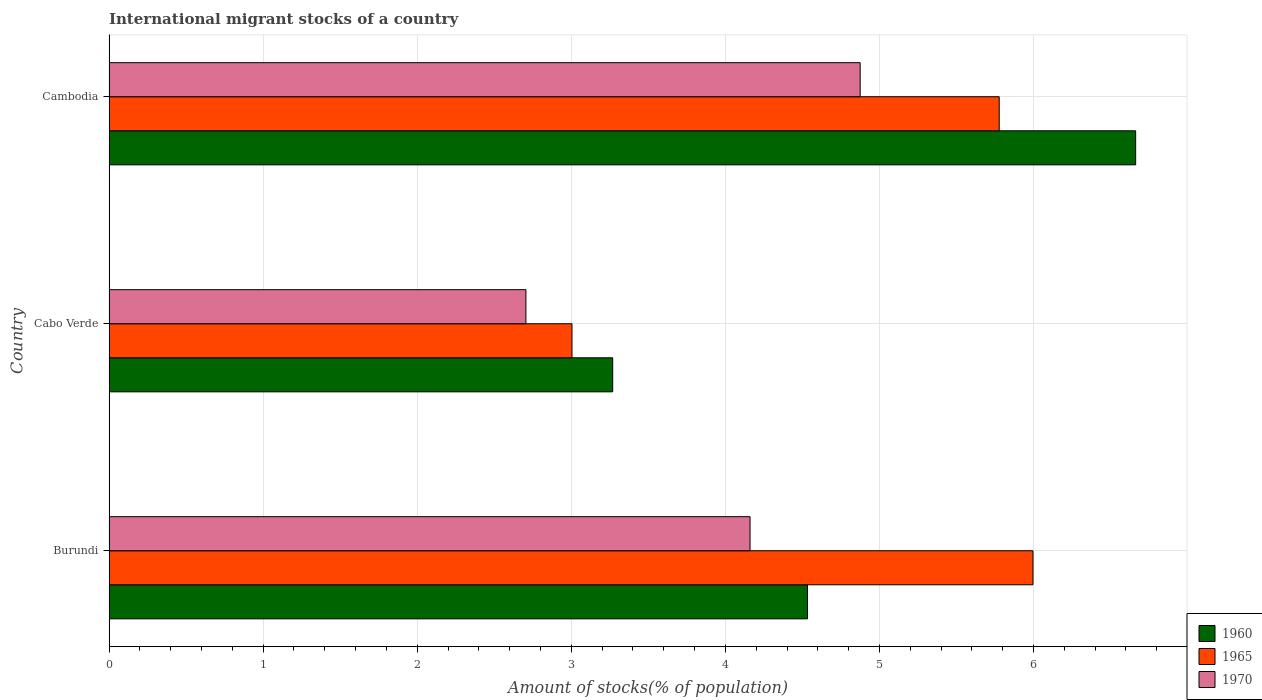How many different coloured bars are there?
Your response must be concise. 3. How many bars are there on the 3rd tick from the bottom?
Your answer should be very brief. 3. What is the label of the 2nd group of bars from the top?
Your answer should be compact. Cabo Verde. What is the amount of stocks in in 1970 in Cabo Verde?
Your response must be concise. 2.71. Across all countries, what is the maximum amount of stocks in in 1960?
Make the answer very short. 6.66. Across all countries, what is the minimum amount of stocks in in 1965?
Your answer should be very brief. 3. In which country was the amount of stocks in in 1960 maximum?
Offer a terse response. Cambodia. In which country was the amount of stocks in in 1970 minimum?
Provide a succinct answer. Cabo Verde. What is the total amount of stocks in in 1965 in the graph?
Your response must be concise. 14.78. What is the difference between the amount of stocks in in 1970 in Burundi and that in Cabo Verde?
Your answer should be compact. 1.45. What is the difference between the amount of stocks in in 1965 in Burundi and the amount of stocks in in 1960 in Cambodia?
Keep it short and to the point. -0.67. What is the average amount of stocks in in 1965 per country?
Give a very brief answer. 4.93. What is the difference between the amount of stocks in in 1965 and amount of stocks in in 1970 in Cambodia?
Keep it short and to the point. 0.9. In how many countries, is the amount of stocks in in 1960 greater than 6.4 %?
Give a very brief answer. 1. What is the ratio of the amount of stocks in in 1960 in Cabo Verde to that in Cambodia?
Your answer should be compact. 0.49. What is the difference between the highest and the second highest amount of stocks in in 1965?
Your answer should be compact. 0.22. What is the difference between the highest and the lowest amount of stocks in in 1965?
Provide a short and direct response. 2.99. Is the sum of the amount of stocks in in 1960 in Cabo Verde and Cambodia greater than the maximum amount of stocks in in 1965 across all countries?
Offer a very short reply. Yes. What does the 1st bar from the top in Burundi represents?
Make the answer very short. 1970. What does the 3rd bar from the bottom in Burundi represents?
Offer a terse response. 1970. How many bars are there?
Offer a terse response. 9. Are all the bars in the graph horizontal?
Offer a very short reply. Yes. What is the difference between two consecutive major ticks on the X-axis?
Your answer should be very brief. 1. Does the graph contain any zero values?
Your answer should be compact. No. How many legend labels are there?
Your answer should be compact. 3. What is the title of the graph?
Your answer should be compact. International migrant stocks of a country. What is the label or title of the X-axis?
Offer a very short reply. Amount of stocks(% of population). What is the Amount of stocks(% of population) in 1960 in Burundi?
Ensure brevity in your answer.  4.53. What is the Amount of stocks(% of population) in 1965 in Burundi?
Provide a succinct answer. 6. What is the Amount of stocks(% of population) of 1970 in Burundi?
Provide a succinct answer. 4.16. What is the Amount of stocks(% of population) in 1960 in Cabo Verde?
Your response must be concise. 3.27. What is the Amount of stocks(% of population) in 1965 in Cabo Verde?
Provide a short and direct response. 3. What is the Amount of stocks(% of population) of 1970 in Cabo Verde?
Your response must be concise. 2.71. What is the Amount of stocks(% of population) in 1960 in Cambodia?
Provide a succinct answer. 6.66. What is the Amount of stocks(% of population) in 1965 in Cambodia?
Offer a very short reply. 5.78. What is the Amount of stocks(% of population) of 1970 in Cambodia?
Provide a short and direct response. 4.87. Across all countries, what is the maximum Amount of stocks(% of population) of 1960?
Provide a short and direct response. 6.66. Across all countries, what is the maximum Amount of stocks(% of population) in 1965?
Your answer should be compact. 6. Across all countries, what is the maximum Amount of stocks(% of population) of 1970?
Provide a short and direct response. 4.87. Across all countries, what is the minimum Amount of stocks(% of population) in 1960?
Provide a succinct answer. 3.27. Across all countries, what is the minimum Amount of stocks(% of population) in 1965?
Your response must be concise. 3. Across all countries, what is the minimum Amount of stocks(% of population) in 1970?
Make the answer very short. 2.71. What is the total Amount of stocks(% of population) in 1960 in the graph?
Your answer should be very brief. 14.46. What is the total Amount of stocks(% of population) in 1965 in the graph?
Make the answer very short. 14.78. What is the total Amount of stocks(% of population) of 1970 in the graph?
Give a very brief answer. 11.74. What is the difference between the Amount of stocks(% of population) in 1960 in Burundi and that in Cabo Verde?
Make the answer very short. 1.26. What is the difference between the Amount of stocks(% of population) of 1965 in Burundi and that in Cabo Verde?
Keep it short and to the point. 2.99. What is the difference between the Amount of stocks(% of population) of 1970 in Burundi and that in Cabo Verde?
Offer a terse response. 1.45. What is the difference between the Amount of stocks(% of population) of 1960 in Burundi and that in Cambodia?
Ensure brevity in your answer.  -2.13. What is the difference between the Amount of stocks(% of population) of 1965 in Burundi and that in Cambodia?
Provide a short and direct response. 0.22. What is the difference between the Amount of stocks(% of population) in 1970 in Burundi and that in Cambodia?
Provide a short and direct response. -0.71. What is the difference between the Amount of stocks(% of population) of 1960 in Cabo Verde and that in Cambodia?
Give a very brief answer. -3.39. What is the difference between the Amount of stocks(% of population) of 1965 in Cabo Verde and that in Cambodia?
Offer a terse response. -2.77. What is the difference between the Amount of stocks(% of population) in 1970 in Cabo Verde and that in Cambodia?
Make the answer very short. -2.17. What is the difference between the Amount of stocks(% of population) of 1960 in Burundi and the Amount of stocks(% of population) of 1965 in Cabo Verde?
Offer a terse response. 1.53. What is the difference between the Amount of stocks(% of population) in 1960 in Burundi and the Amount of stocks(% of population) in 1970 in Cabo Verde?
Offer a terse response. 1.83. What is the difference between the Amount of stocks(% of population) in 1965 in Burundi and the Amount of stocks(% of population) in 1970 in Cabo Verde?
Provide a succinct answer. 3.29. What is the difference between the Amount of stocks(% of population) in 1960 in Burundi and the Amount of stocks(% of population) in 1965 in Cambodia?
Offer a terse response. -1.24. What is the difference between the Amount of stocks(% of population) of 1960 in Burundi and the Amount of stocks(% of population) of 1970 in Cambodia?
Offer a terse response. -0.34. What is the difference between the Amount of stocks(% of population) of 1965 in Burundi and the Amount of stocks(% of population) of 1970 in Cambodia?
Give a very brief answer. 1.12. What is the difference between the Amount of stocks(% of population) of 1960 in Cabo Verde and the Amount of stocks(% of population) of 1965 in Cambodia?
Make the answer very short. -2.51. What is the difference between the Amount of stocks(% of population) in 1960 in Cabo Verde and the Amount of stocks(% of population) in 1970 in Cambodia?
Ensure brevity in your answer.  -1.61. What is the difference between the Amount of stocks(% of population) of 1965 in Cabo Verde and the Amount of stocks(% of population) of 1970 in Cambodia?
Offer a terse response. -1.87. What is the average Amount of stocks(% of population) in 1960 per country?
Keep it short and to the point. 4.82. What is the average Amount of stocks(% of population) of 1965 per country?
Keep it short and to the point. 4.93. What is the average Amount of stocks(% of population) in 1970 per country?
Keep it short and to the point. 3.91. What is the difference between the Amount of stocks(% of population) in 1960 and Amount of stocks(% of population) in 1965 in Burundi?
Give a very brief answer. -1.46. What is the difference between the Amount of stocks(% of population) of 1960 and Amount of stocks(% of population) of 1970 in Burundi?
Provide a short and direct response. 0.37. What is the difference between the Amount of stocks(% of population) in 1965 and Amount of stocks(% of population) in 1970 in Burundi?
Make the answer very short. 1.84. What is the difference between the Amount of stocks(% of population) of 1960 and Amount of stocks(% of population) of 1965 in Cabo Verde?
Keep it short and to the point. 0.26. What is the difference between the Amount of stocks(% of population) of 1960 and Amount of stocks(% of population) of 1970 in Cabo Verde?
Provide a short and direct response. 0.56. What is the difference between the Amount of stocks(% of population) of 1965 and Amount of stocks(% of population) of 1970 in Cabo Verde?
Ensure brevity in your answer.  0.3. What is the difference between the Amount of stocks(% of population) of 1960 and Amount of stocks(% of population) of 1965 in Cambodia?
Your response must be concise. 0.89. What is the difference between the Amount of stocks(% of population) in 1960 and Amount of stocks(% of population) in 1970 in Cambodia?
Provide a succinct answer. 1.79. What is the difference between the Amount of stocks(% of population) of 1965 and Amount of stocks(% of population) of 1970 in Cambodia?
Offer a terse response. 0.9. What is the ratio of the Amount of stocks(% of population) in 1960 in Burundi to that in Cabo Verde?
Your answer should be compact. 1.39. What is the ratio of the Amount of stocks(% of population) in 1965 in Burundi to that in Cabo Verde?
Ensure brevity in your answer.  2. What is the ratio of the Amount of stocks(% of population) of 1970 in Burundi to that in Cabo Verde?
Keep it short and to the point. 1.54. What is the ratio of the Amount of stocks(% of population) of 1960 in Burundi to that in Cambodia?
Give a very brief answer. 0.68. What is the ratio of the Amount of stocks(% of population) of 1965 in Burundi to that in Cambodia?
Keep it short and to the point. 1.04. What is the ratio of the Amount of stocks(% of population) of 1970 in Burundi to that in Cambodia?
Ensure brevity in your answer.  0.85. What is the ratio of the Amount of stocks(% of population) of 1960 in Cabo Verde to that in Cambodia?
Ensure brevity in your answer.  0.49. What is the ratio of the Amount of stocks(% of population) in 1965 in Cabo Verde to that in Cambodia?
Provide a short and direct response. 0.52. What is the ratio of the Amount of stocks(% of population) of 1970 in Cabo Verde to that in Cambodia?
Give a very brief answer. 0.56. What is the difference between the highest and the second highest Amount of stocks(% of population) of 1960?
Provide a short and direct response. 2.13. What is the difference between the highest and the second highest Amount of stocks(% of population) of 1965?
Provide a succinct answer. 0.22. What is the difference between the highest and the second highest Amount of stocks(% of population) in 1970?
Offer a very short reply. 0.71. What is the difference between the highest and the lowest Amount of stocks(% of population) of 1960?
Offer a terse response. 3.39. What is the difference between the highest and the lowest Amount of stocks(% of population) in 1965?
Keep it short and to the point. 2.99. What is the difference between the highest and the lowest Amount of stocks(% of population) of 1970?
Offer a very short reply. 2.17. 